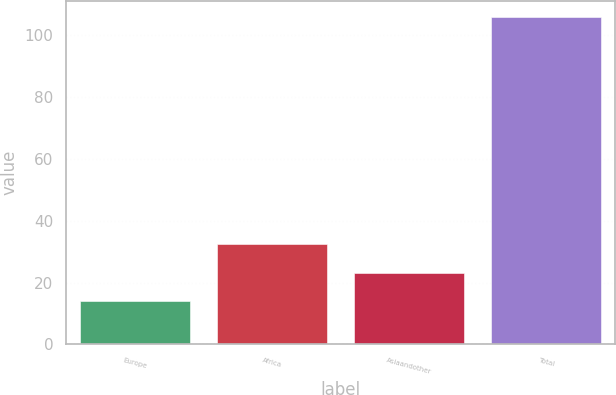Convert chart to OTSL. <chart><loc_0><loc_0><loc_500><loc_500><bar_chart><fcel>Europe<fcel>Africa<fcel>Asiaandother<fcel>Total<nl><fcel>14<fcel>32.4<fcel>23.2<fcel>106<nl></chart> 